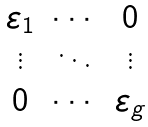<formula> <loc_0><loc_0><loc_500><loc_500>\begin{matrix} \varepsilon _ { 1 } & \cdots & 0 \\ \vdots & \ddots & \vdots \\ 0 & \cdots & \varepsilon _ { g } \end{matrix}</formula> 